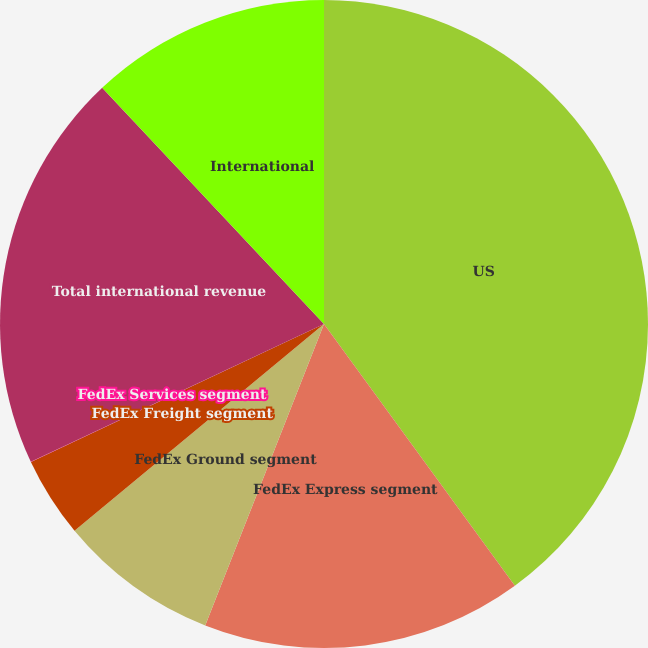Convert chart to OTSL. <chart><loc_0><loc_0><loc_500><loc_500><pie_chart><fcel>US<fcel>FedEx Express segment<fcel>FedEx Ground segment<fcel>FedEx Freight segment<fcel>FedEx Services segment<fcel>Total international revenue<fcel>International<nl><fcel>39.97%<fcel>16.0%<fcel>8.01%<fcel>4.01%<fcel>0.01%<fcel>19.99%<fcel>12.0%<nl></chart> 